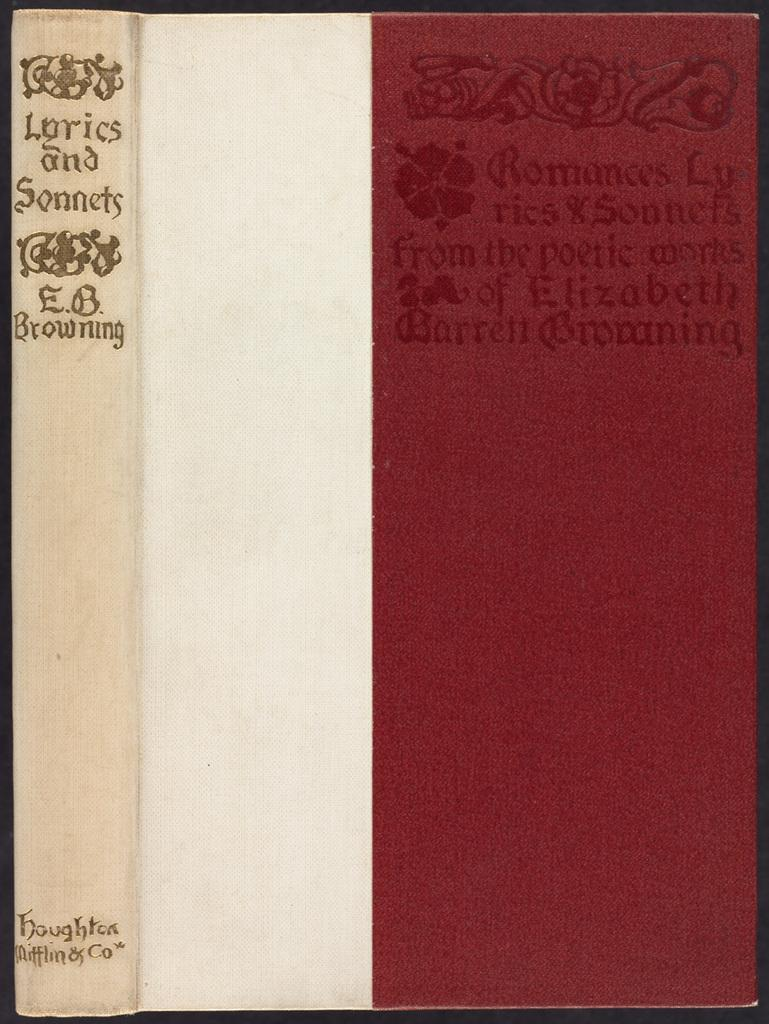<image>
Relay a brief, clear account of the picture shown. The books contains a collection of lyrics and sonnets. 